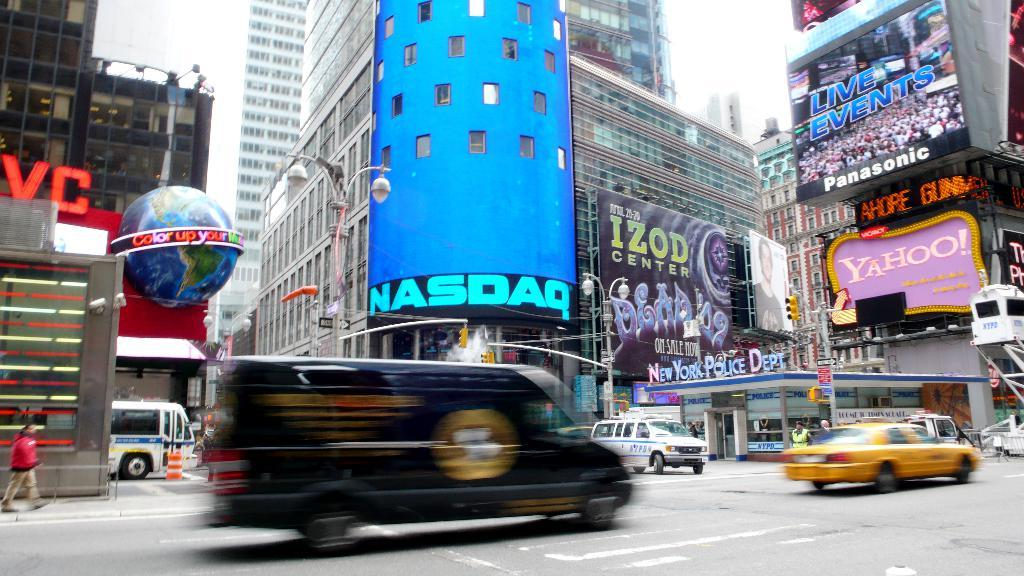<image>
Give a short and clear explanation of the subsequent image. A big blue Nasdaq sign hangs near an Izod billboard. 